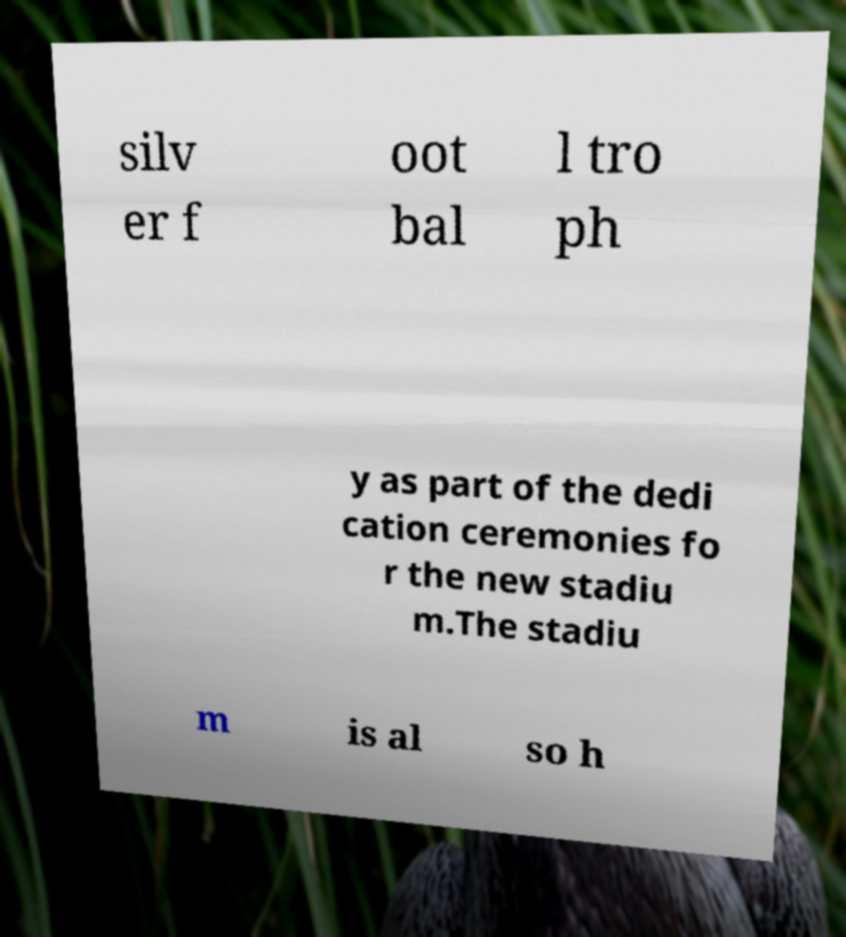Please read and relay the text visible in this image. What does it say? silv er f oot bal l tro ph y as part of the dedi cation ceremonies fo r the new stadiu m.The stadiu m is al so h 